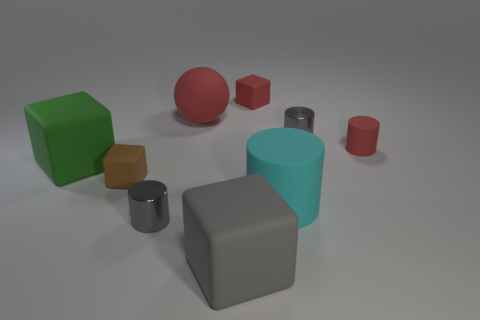What number of cylinders are green matte objects or brown matte objects?
Provide a succinct answer. 0. How many red things are in front of the small gray object that is behind the metallic thing that is in front of the green rubber block?
Offer a very short reply. 1. There is a small cylinder that is the same color as the sphere; what is its material?
Offer a terse response. Rubber. Is the number of large red matte objects greater than the number of tiny yellow shiny things?
Provide a short and direct response. Yes. Does the red cylinder have the same size as the brown matte thing?
Your answer should be very brief. Yes. How many objects are red rubber objects or red cylinders?
Offer a very short reply. 3. There is a tiny shiny object to the right of the small gray thing that is in front of the tiny red matte object to the right of the large matte cylinder; what shape is it?
Offer a terse response. Cylinder. Is the object that is left of the tiny brown matte cube made of the same material as the small gray object in front of the tiny red cylinder?
Give a very brief answer. No. There is a small red object that is the same shape as the cyan rubber object; what material is it?
Your answer should be compact. Rubber. Is there any other thing that has the same size as the brown rubber thing?
Ensure brevity in your answer.  Yes. 